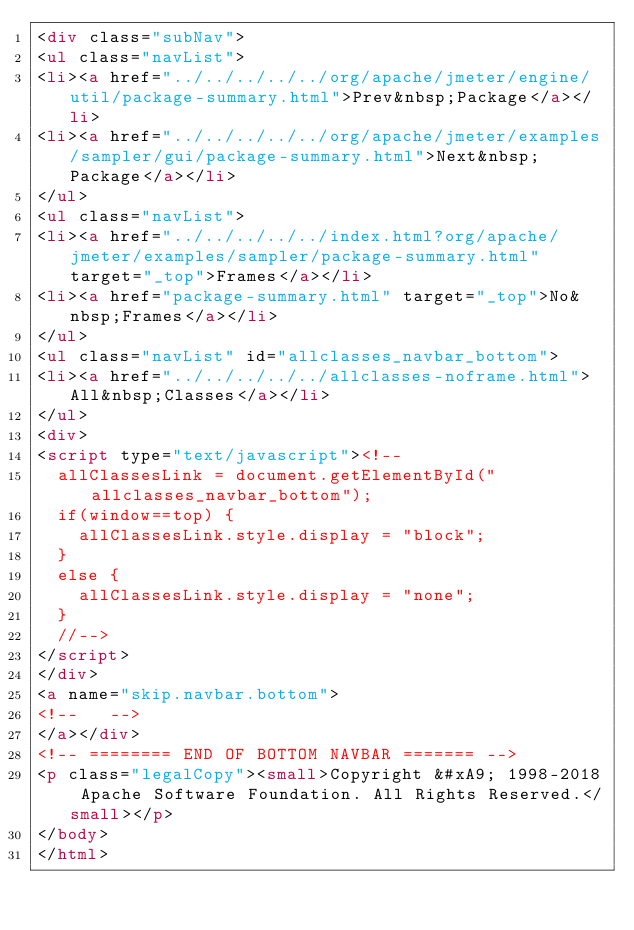<code> <loc_0><loc_0><loc_500><loc_500><_HTML_><div class="subNav">
<ul class="navList">
<li><a href="../../../../../org/apache/jmeter/engine/util/package-summary.html">Prev&nbsp;Package</a></li>
<li><a href="../../../../../org/apache/jmeter/examples/sampler/gui/package-summary.html">Next&nbsp;Package</a></li>
</ul>
<ul class="navList">
<li><a href="../../../../../index.html?org/apache/jmeter/examples/sampler/package-summary.html" target="_top">Frames</a></li>
<li><a href="package-summary.html" target="_top">No&nbsp;Frames</a></li>
</ul>
<ul class="navList" id="allclasses_navbar_bottom">
<li><a href="../../../../../allclasses-noframe.html">All&nbsp;Classes</a></li>
</ul>
<div>
<script type="text/javascript"><!--
  allClassesLink = document.getElementById("allclasses_navbar_bottom");
  if(window==top) {
    allClassesLink.style.display = "block";
  }
  else {
    allClassesLink.style.display = "none";
  }
  //-->
</script>
</div>
<a name="skip.navbar.bottom">
<!--   -->
</a></div>
<!-- ======== END OF BOTTOM NAVBAR ======= -->
<p class="legalCopy"><small>Copyright &#xA9; 1998-2018 Apache Software Foundation. All Rights Reserved.</small></p>
</body>
</html>
</code> 